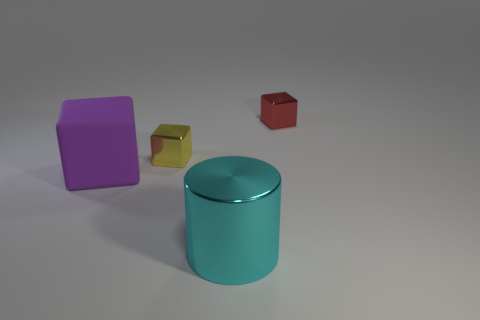Add 2 red shiny objects. How many objects exist? 6 Subtract all cylinders. How many objects are left? 3 Add 3 cylinders. How many cylinders are left? 4 Add 3 green spheres. How many green spheres exist? 3 Subtract 1 cyan cylinders. How many objects are left? 3 Subtract all large purple matte blocks. Subtract all blue metallic cylinders. How many objects are left? 3 